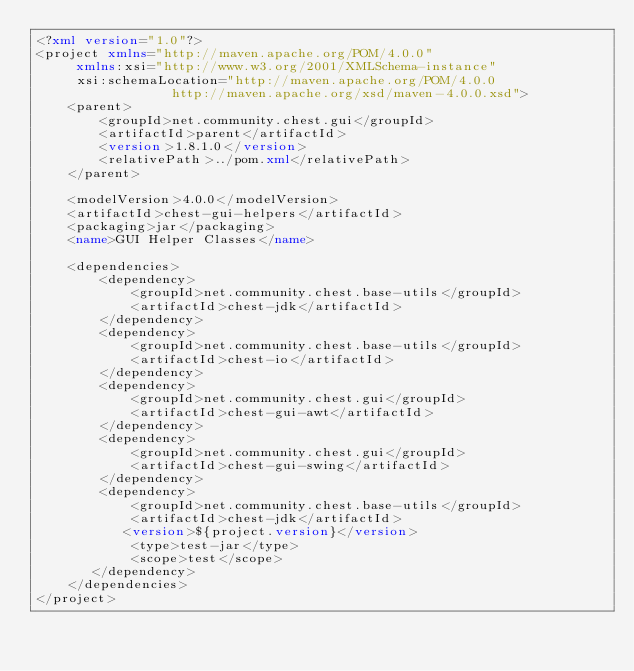<code> <loc_0><loc_0><loc_500><loc_500><_XML_><?xml version="1.0"?>
<project xmlns="http://maven.apache.org/POM/4.0.0"
     xmlns:xsi="http://www.w3.org/2001/XMLSchema-instance"
     xsi:schemaLocation="http://maven.apache.org/POM/4.0.0
                 http://maven.apache.org/xsd/maven-4.0.0.xsd">
    <parent>
        <groupId>net.community.chest.gui</groupId>
        <artifactId>parent</artifactId>
        <version>1.8.1.0</version>
        <relativePath>../pom.xml</relativePath>
    </parent>

    <modelVersion>4.0.0</modelVersion>
    <artifactId>chest-gui-helpers</artifactId>
    <packaging>jar</packaging>
    <name>GUI Helper Classes</name>

    <dependencies>
        <dependency>
            <groupId>net.community.chest.base-utils</groupId>
            <artifactId>chest-jdk</artifactId>
        </dependency>
        <dependency>
            <groupId>net.community.chest.base-utils</groupId>
            <artifactId>chest-io</artifactId>
        </dependency>
        <dependency>
            <groupId>net.community.chest.gui</groupId>
            <artifactId>chest-gui-awt</artifactId>
        </dependency>
        <dependency>
            <groupId>net.community.chest.gui</groupId>
            <artifactId>chest-gui-swing</artifactId>
        </dependency>
        <dependency>
            <groupId>net.community.chest.base-utils</groupId>
            <artifactId>chest-jdk</artifactId>
           <version>${project.version}</version>
            <type>test-jar</type>
            <scope>test</scope>
       </dependency>
    </dependencies>
</project>
</code> 